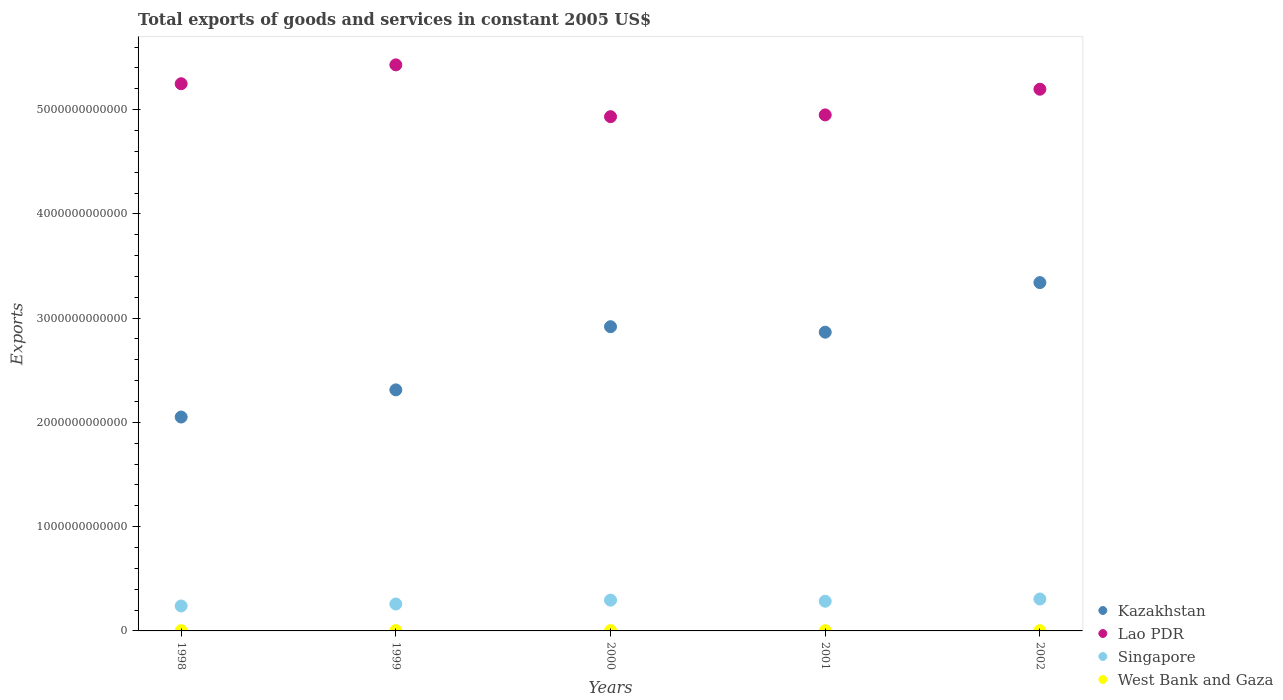How many different coloured dotlines are there?
Offer a terse response. 4. What is the total exports of goods and services in West Bank and Gaza in 2000?
Keep it short and to the point. 3.59e+09. Across all years, what is the maximum total exports of goods and services in Kazakhstan?
Keep it short and to the point. 3.34e+12. Across all years, what is the minimum total exports of goods and services in West Bank and Gaza?
Provide a succinct answer. 2.28e+09. In which year was the total exports of goods and services in Kazakhstan minimum?
Your answer should be compact. 1998. What is the total total exports of goods and services in Kazakhstan in the graph?
Give a very brief answer. 1.35e+13. What is the difference between the total exports of goods and services in West Bank and Gaza in 1998 and that in 2002?
Provide a short and direct response. 4.20e+08. What is the difference between the total exports of goods and services in Singapore in 2002 and the total exports of goods and services in Kazakhstan in 2000?
Your answer should be compact. -2.61e+12. What is the average total exports of goods and services in Lao PDR per year?
Your response must be concise. 5.15e+12. In the year 1998, what is the difference between the total exports of goods and services in Singapore and total exports of goods and services in Kazakhstan?
Provide a succinct answer. -1.81e+12. What is the ratio of the total exports of goods and services in Kazakhstan in 1998 to that in 1999?
Offer a very short reply. 0.89. Is the difference between the total exports of goods and services in Singapore in 1999 and 2002 greater than the difference between the total exports of goods and services in Kazakhstan in 1999 and 2002?
Your answer should be very brief. Yes. What is the difference between the highest and the second highest total exports of goods and services in West Bank and Gaza?
Your answer should be very brief. 4.78e+08. What is the difference between the highest and the lowest total exports of goods and services in Kazakhstan?
Your response must be concise. 1.29e+12. In how many years, is the total exports of goods and services in Kazakhstan greater than the average total exports of goods and services in Kazakhstan taken over all years?
Your answer should be compact. 3. Is the total exports of goods and services in Singapore strictly less than the total exports of goods and services in West Bank and Gaza over the years?
Your answer should be compact. No. What is the difference between two consecutive major ticks on the Y-axis?
Keep it short and to the point. 1.00e+12. Does the graph contain any zero values?
Provide a succinct answer. No. Does the graph contain grids?
Ensure brevity in your answer.  No. How are the legend labels stacked?
Your answer should be compact. Vertical. What is the title of the graph?
Provide a short and direct response. Total exports of goods and services in constant 2005 US$. Does "Guinea" appear as one of the legend labels in the graph?
Keep it short and to the point. No. What is the label or title of the Y-axis?
Provide a succinct answer. Exports. What is the Exports in Kazakhstan in 1998?
Your answer should be compact. 2.05e+12. What is the Exports of Lao PDR in 1998?
Keep it short and to the point. 5.25e+12. What is the Exports in Singapore in 1998?
Your answer should be compact. 2.39e+11. What is the Exports of West Bank and Gaza in 1998?
Ensure brevity in your answer.  2.70e+09. What is the Exports in Kazakhstan in 1999?
Offer a very short reply. 2.31e+12. What is the Exports in Lao PDR in 1999?
Keep it short and to the point. 5.43e+12. What is the Exports of Singapore in 1999?
Offer a terse response. 2.58e+11. What is the Exports of West Bank and Gaza in 1999?
Ensure brevity in your answer.  3.11e+09. What is the Exports of Kazakhstan in 2000?
Your response must be concise. 2.92e+12. What is the Exports of Lao PDR in 2000?
Ensure brevity in your answer.  4.93e+12. What is the Exports in Singapore in 2000?
Keep it short and to the point. 2.95e+11. What is the Exports of West Bank and Gaza in 2000?
Provide a succinct answer. 3.59e+09. What is the Exports of Kazakhstan in 2001?
Keep it short and to the point. 2.87e+12. What is the Exports in Lao PDR in 2001?
Provide a succinct answer. 4.95e+12. What is the Exports of Singapore in 2001?
Offer a very short reply. 2.85e+11. What is the Exports of West Bank and Gaza in 2001?
Your response must be concise. 2.48e+09. What is the Exports in Kazakhstan in 2002?
Make the answer very short. 3.34e+12. What is the Exports of Lao PDR in 2002?
Your answer should be very brief. 5.20e+12. What is the Exports in Singapore in 2002?
Provide a succinct answer. 3.06e+11. What is the Exports in West Bank and Gaza in 2002?
Provide a succinct answer. 2.28e+09. Across all years, what is the maximum Exports of Kazakhstan?
Your answer should be compact. 3.34e+12. Across all years, what is the maximum Exports in Lao PDR?
Your response must be concise. 5.43e+12. Across all years, what is the maximum Exports in Singapore?
Ensure brevity in your answer.  3.06e+11. Across all years, what is the maximum Exports in West Bank and Gaza?
Keep it short and to the point. 3.59e+09. Across all years, what is the minimum Exports in Kazakhstan?
Offer a terse response. 2.05e+12. Across all years, what is the minimum Exports in Lao PDR?
Give a very brief answer. 4.93e+12. Across all years, what is the minimum Exports of Singapore?
Your response must be concise. 2.39e+11. Across all years, what is the minimum Exports in West Bank and Gaza?
Make the answer very short. 2.28e+09. What is the total Exports of Kazakhstan in the graph?
Keep it short and to the point. 1.35e+13. What is the total Exports in Lao PDR in the graph?
Give a very brief answer. 2.58e+13. What is the total Exports of Singapore in the graph?
Ensure brevity in your answer.  1.38e+12. What is the total Exports in West Bank and Gaza in the graph?
Offer a very short reply. 1.42e+1. What is the difference between the Exports in Kazakhstan in 1998 and that in 1999?
Give a very brief answer. -2.61e+11. What is the difference between the Exports in Lao PDR in 1998 and that in 1999?
Your answer should be compact. -1.81e+11. What is the difference between the Exports in Singapore in 1998 and that in 1999?
Offer a terse response. -1.87e+1. What is the difference between the Exports of West Bank and Gaza in 1998 and that in 1999?
Ensure brevity in your answer.  -4.09e+08. What is the difference between the Exports of Kazakhstan in 1998 and that in 2000?
Ensure brevity in your answer.  -8.66e+11. What is the difference between the Exports in Lao PDR in 1998 and that in 2000?
Make the answer very short. 3.16e+11. What is the difference between the Exports of Singapore in 1998 and that in 2000?
Give a very brief answer. -5.60e+1. What is the difference between the Exports of West Bank and Gaza in 1998 and that in 2000?
Offer a terse response. -8.88e+08. What is the difference between the Exports in Kazakhstan in 1998 and that in 2001?
Offer a terse response. -8.14e+11. What is the difference between the Exports of Lao PDR in 1998 and that in 2001?
Provide a succinct answer. 2.99e+11. What is the difference between the Exports in Singapore in 1998 and that in 2001?
Offer a very short reply. -4.55e+1. What is the difference between the Exports of West Bank and Gaza in 1998 and that in 2001?
Provide a succinct answer. 2.17e+08. What is the difference between the Exports in Kazakhstan in 1998 and that in 2002?
Give a very brief answer. -1.29e+12. What is the difference between the Exports of Lao PDR in 1998 and that in 2002?
Give a very brief answer. 5.26e+1. What is the difference between the Exports of Singapore in 1998 and that in 2002?
Give a very brief answer. -6.69e+1. What is the difference between the Exports in West Bank and Gaza in 1998 and that in 2002?
Provide a short and direct response. 4.20e+08. What is the difference between the Exports in Kazakhstan in 1999 and that in 2000?
Your answer should be compact. -6.06e+11. What is the difference between the Exports in Lao PDR in 1999 and that in 2000?
Provide a short and direct response. 4.97e+11. What is the difference between the Exports of Singapore in 1999 and that in 2000?
Offer a terse response. -3.72e+1. What is the difference between the Exports in West Bank and Gaza in 1999 and that in 2000?
Your answer should be very brief. -4.78e+08. What is the difference between the Exports of Kazakhstan in 1999 and that in 2001?
Make the answer very short. -5.53e+11. What is the difference between the Exports of Lao PDR in 1999 and that in 2001?
Ensure brevity in your answer.  4.80e+11. What is the difference between the Exports of Singapore in 1999 and that in 2001?
Provide a short and direct response. -2.68e+1. What is the difference between the Exports in West Bank and Gaza in 1999 and that in 2001?
Provide a short and direct response. 6.27e+08. What is the difference between the Exports in Kazakhstan in 1999 and that in 2002?
Your answer should be compact. -1.03e+12. What is the difference between the Exports of Lao PDR in 1999 and that in 2002?
Give a very brief answer. 2.34e+11. What is the difference between the Exports of Singapore in 1999 and that in 2002?
Give a very brief answer. -4.81e+1. What is the difference between the Exports in West Bank and Gaza in 1999 and that in 2002?
Give a very brief answer. 8.29e+08. What is the difference between the Exports of Kazakhstan in 2000 and that in 2001?
Your answer should be compact. 5.25e+1. What is the difference between the Exports in Lao PDR in 2000 and that in 2001?
Your answer should be compact. -1.71e+1. What is the difference between the Exports in Singapore in 2000 and that in 2001?
Make the answer very short. 1.04e+1. What is the difference between the Exports in West Bank and Gaza in 2000 and that in 2001?
Give a very brief answer. 1.10e+09. What is the difference between the Exports of Kazakhstan in 2000 and that in 2002?
Offer a very short reply. -4.23e+11. What is the difference between the Exports of Lao PDR in 2000 and that in 2002?
Offer a terse response. -2.63e+11. What is the difference between the Exports in Singapore in 2000 and that in 2002?
Offer a terse response. -1.09e+1. What is the difference between the Exports in West Bank and Gaza in 2000 and that in 2002?
Your answer should be very brief. 1.31e+09. What is the difference between the Exports of Kazakhstan in 2001 and that in 2002?
Ensure brevity in your answer.  -4.76e+11. What is the difference between the Exports of Lao PDR in 2001 and that in 2002?
Your response must be concise. -2.46e+11. What is the difference between the Exports of Singapore in 2001 and that in 2002?
Give a very brief answer. -2.13e+1. What is the difference between the Exports in West Bank and Gaza in 2001 and that in 2002?
Keep it short and to the point. 2.03e+08. What is the difference between the Exports of Kazakhstan in 1998 and the Exports of Lao PDR in 1999?
Your response must be concise. -3.38e+12. What is the difference between the Exports in Kazakhstan in 1998 and the Exports in Singapore in 1999?
Offer a terse response. 1.79e+12. What is the difference between the Exports in Kazakhstan in 1998 and the Exports in West Bank and Gaza in 1999?
Provide a short and direct response. 2.05e+12. What is the difference between the Exports in Lao PDR in 1998 and the Exports in Singapore in 1999?
Provide a succinct answer. 4.99e+12. What is the difference between the Exports of Lao PDR in 1998 and the Exports of West Bank and Gaza in 1999?
Offer a very short reply. 5.25e+12. What is the difference between the Exports of Singapore in 1998 and the Exports of West Bank and Gaza in 1999?
Your answer should be compact. 2.36e+11. What is the difference between the Exports in Kazakhstan in 1998 and the Exports in Lao PDR in 2000?
Offer a very short reply. -2.88e+12. What is the difference between the Exports in Kazakhstan in 1998 and the Exports in Singapore in 2000?
Your response must be concise. 1.76e+12. What is the difference between the Exports of Kazakhstan in 1998 and the Exports of West Bank and Gaza in 2000?
Provide a short and direct response. 2.05e+12. What is the difference between the Exports in Lao PDR in 1998 and the Exports in Singapore in 2000?
Offer a very short reply. 4.95e+12. What is the difference between the Exports in Lao PDR in 1998 and the Exports in West Bank and Gaza in 2000?
Make the answer very short. 5.24e+12. What is the difference between the Exports of Singapore in 1998 and the Exports of West Bank and Gaza in 2000?
Your answer should be very brief. 2.36e+11. What is the difference between the Exports in Kazakhstan in 1998 and the Exports in Lao PDR in 2001?
Provide a succinct answer. -2.90e+12. What is the difference between the Exports of Kazakhstan in 1998 and the Exports of Singapore in 2001?
Ensure brevity in your answer.  1.77e+12. What is the difference between the Exports in Kazakhstan in 1998 and the Exports in West Bank and Gaza in 2001?
Your response must be concise. 2.05e+12. What is the difference between the Exports in Lao PDR in 1998 and the Exports in Singapore in 2001?
Keep it short and to the point. 4.96e+12. What is the difference between the Exports in Lao PDR in 1998 and the Exports in West Bank and Gaza in 2001?
Keep it short and to the point. 5.25e+12. What is the difference between the Exports in Singapore in 1998 and the Exports in West Bank and Gaza in 2001?
Give a very brief answer. 2.37e+11. What is the difference between the Exports of Kazakhstan in 1998 and the Exports of Lao PDR in 2002?
Provide a short and direct response. -3.14e+12. What is the difference between the Exports in Kazakhstan in 1998 and the Exports in Singapore in 2002?
Your answer should be very brief. 1.75e+12. What is the difference between the Exports of Kazakhstan in 1998 and the Exports of West Bank and Gaza in 2002?
Offer a very short reply. 2.05e+12. What is the difference between the Exports of Lao PDR in 1998 and the Exports of Singapore in 2002?
Keep it short and to the point. 4.94e+12. What is the difference between the Exports of Lao PDR in 1998 and the Exports of West Bank and Gaza in 2002?
Your response must be concise. 5.25e+12. What is the difference between the Exports in Singapore in 1998 and the Exports in West Bank and Gaza in 2002?
Keep it short and to the point. 2.37e+11. What is the difference between the Exports in Kazakhstan in 1999 and the Exports in Lao PDR in 2000?
Offer a very short reply. -2.62e+12. What is the difference between the Exports of Kazakhstan in 1999 and the Exports of Singapore in 2000?
Offer a very short reply. 2.02e+12. What is the difference between the Exports of Kazakhstan in 1999 and the Exports of West Bank and Gaza in 2000?
Ensure brevity in your answer.  2.31e+12. What is the difference between the Exports in Lao PDR in 1999 and the Exports in Singapore in 2000?
Your answer should be very brief. 5.13e+12. What is the difference between the Exports of Lao PDR in 1999 and the Exports of West Bank and Gaza in 2000?
Your answer should be compact. 5.43e+12. What is the difference between the Exports of Singapore in 1999 and the Exports of West Bank and Gaza in 2000?
Your answer should be compact. 2.54e+11. What is the difference between the Exports of Kazakhstan in 1999 and the Exports of Lao PDR in 2001?
Offer a very short reply. -2.64e+12. What is the difference between the Exports in Kazakhstan in 1999 and the Exports in Singapore in 2001?
Provide a succinct answer. 2.03e+12. What is the difference between the Exports in Kazakhstan in 1999 and the Exports in West Bank and Gaza in 2001?
Offer a very short reply. 2.31e+12. What is the difference between the Exports in Lao PDR in 1999 and the Exports in Singapore in 2001?
Your answer should be very brief. 5.14e+12. What is the difference between the Exports in Lao PDR in 1999 and the Exports in West Bank and Gaza in 2001?
Give a very brief answer. 5.43e+12. What is the difference between the Exports in Singapore in 1999 and the Exports in West Bank and Gaza in 2001?
Your answer should be compact. 2.56e+11. What is the difference between the Exports of Kazakhstan in 1999 and the Exports of Lao PDR in 2002?
Keep it short and to the point. -2.88e+12. What is the difference between the Exports in Kazakhstan in 1999 and the Exports in Singapore in 2002?
Your answer should be very brief. 2.01e+12. What is the difference between the Exports of Kazakhstan in 1999 and the Exports of West Bank and Gaza in 2002?
Provide a short and direct response. 2.31e+12. What is the difference between the Exports of Lao PDR in 1999 and the Exports of Singapore in 2002?
Provide a succinct answer. 5.12e+12. What is the difference between the Exports of Lao PDR in 1999 and the Exports of West Bank and Gaza in 2002?
Your response must be concise. 5.43e+12. What is the difference between the Exports in Singapore in 1999 and the Exports in West Bank and Gaza in 2002?
Your answer should be very brief. 2.56e+11. What is the difference between the Exports of Kazakhstan in 2000 and the Exports of Lao PDR in 2001?
Your answer should be compact. -2.03e+12. What is the difference between the Exports in Kazakhstan in 2000 and the Exports in Singapore in 2001?
Offer a terse response. 2.63e+12. What is the difference between the Exports of Kazakhstan in 2000 and the Exports of West Bank and Gaza in 2001?
Your answer should be very brief. 2.92e+12. What is the difference between the Exports of Lao PDR in 2000 and the Exports of Singapore in 2001?
Give a very brief answer. 4.65e+12. What is the difference between the Exports of Lao PDR in 2000 and the Exports of West Bank and Gaza in 2001?
Your response must be concise. 4.93e+12. What is the difference between the Exports of Singapore in 2000 and the Exports of West Bank and Gaza in 2001?
Keep it short and to the point. 2.93e+11. What is the difference between the Exports in Kazakhstan in 2000 and the Exports in Lao PDR in 2002?
Ensure brevity in your answer.  -2.28e+12. What is the difference between the Exports of Kazakhstan in 2000 and the Exports of Singapore in 2002?
Keep it short and to the point. 2.61e+12. What is the difference between the Exports in Kazakhstan in 2000 and the Exports in West Bank and Gaza in 2002?
Your response must be concise. 2.92e+12. What is the difference between the Exports of Lao PDR in 2000 and the Exports of Singapore in 2002?
Ensure brevity in your answer.  4.63e+12. What is the difference between the Exports of Lao PDR in 2000 and the Exports of West Bank and Gaza in 2002?
Offer a terse response. 4.93e+12. What is the difference between the Exports of Singapore in 2000 and the Exports of West Bank and Gaza in 2002?
Ensure brevity in your answer.  2.93e+11. What is the difference between the Exports of Kazakhstan in 2001 and the Exports of Lao PDR in 2002?
Provide a short and direct response. -2.33e+12. What is the difference between the Exports of Kazakhstan in 2001 and the Exports of Singapore in 2002?
Make the answer very short. 2.56e+12. What is the difference between the Exports of Kazakhstan in 2001 and the Exports of West Bank and Gaza in 2002?
Provide a succinct answer. 2.86e+12. What is the difference between the Exports in Lao PDR in 2001 and the Exports in Singapore in 2002?
Your response must be concise. 4.64e+12. What is the difference between the Exports of Lao PDR in 2001 and the Exports of West Bank and Gaza in 2002?
Provide a succinct answer. 4.95e+12. What is the difference between the Exports in Singapore in 2001 and the Exports in West Bank and Gaza in 2002?
Offer a very short reply. 2.83e+11. What is the average Exports in Kazakhstan per year?
Provide a succinct answer. 2.70e+12. What is the average Exports of Lao PDR per year?
Give a very brief answer. 5.15e+12. What is the average Exports of Singapore per year?
Provide a succinct answer. 2.77e+11. What is the average Exports of West Bank and Gaza per year?
Your response must be concise. 2.83e+09. In the year 1998, what is the difference between the Exports in Kazakhstan and Exports in Lao PDR?
Your response must be concise. -3.20e+12. In the year 1998, what is the difference between the Exports in Kazakhstan and Exports in Singapore?
Make the answer very short. 1.81e+12. In the year 1998, what is the difference between the Exports of Kazakhstan and Exports of West Bank and Gaza?
Make the answer very short. 2.05e+12. In the year 1998, what is the difference between the Exports of Lao PDR and Exports of Singapore?
Offer a very short reply. 5.01e+12. In the year 1998, what is the difference between the Exports of Lao PDR and Exports of West Bank and Gaza?
Provide a succinct answer. 5.25e+12. In the year 1998, what is the difference between the Exports in Singapore and Exports in West Bank and Gaza?
Make the answer very short. 2.37e+11. In the year 1999, what is the difference between the Exports in Kazakhstan and Exports in Lao PDR?
Ensure brevity in your answer.  -3.12e+12. In the year 1999, what is the difference between the Exports in Kazakhstan and Exports in Singapore?
Your answer should be compact. 2.05e+12. In the year 1999, what is the difference between the Exports in Kazakhstan and Exports in West Bank and Gaza?
Your response must be concise. 2.31e+12. In the year 1999, what is the difference between the Exports in Lao PDR and Exports in Singapore?
Ensure brevity in your answer.  5.17e+12. In the year 1999, what is the difference between the Exports of Lao PDR and Exports of West Bank and Gaza?
Keep it short and to the point. 5.43e+12. In the year 1999, what is the difference between the Exports of Singapore and Exports of West Bank and Gaza?
Ensure brevity in your answer.  2.55e+11. In the year 2000, what is the difference between the Exports of Kazakhstan and Exports of Lao PDR?
Your answer should be very brief. -2.01e+12. In the year 2000, what is the difference between the Exports of Kazakhstan and Exports of Singapore?
Provide a short and direct response. 2.62e+12. In the year 2000, what is the difference between the Exports in Kazakhstan and Exports in West Bank and Gaza?
Give a very brief answer. 2.91e+12. In the year 2000, what is the difference between the Exports in Lao PDR and Exports in Singapore?
Provide a succinct answer. 4.64e+12. In the year 2000, what is the difference between the Exports in Lao PDR and Exports in West Bank and Gaza?
Give a very brief answer. 4.93e+12. In the year 2000, what is the difference between the Exports in Singapore and Exports in West Bank and Gaza?
Provide a succinct answer. 2.92e+11. In the year 2001, what is the difference between the Exports of Kazakhstan and Exports of Lao PDR?
Offer a very short reply. -2.08e+12. In the year 2001, what is the difference between the Exports in Kazakhstan and Exports in Singapore?
Offer a very short reply. 2.58e+12. In the year 2001, what is the difference between the Exports in Kazakhstan and Exports in West Bank and Gaza?
Offer a terse response. 2.86e+12. In the year 2001, what is the difference between the Exports in Lao PDR and Exports in Singapore?
Your answer should be very brief. 4.66e+12. In the year 2001, what is the difference between the Exports in Lao PDR and Exports in West Bank and Gaza?
Your answer should be very brief. 4.95e+12. In the year 2001, what is the difference between the Exports in Singapore and Exports in West Bank and Gaza?
Provide a succinct answer. 2.82e+11. In the year 2002, what is the difference between the Exports in Kazakhstan and Exports in Lao PDR?
Make the answer very short. -1.85e+12. In the year 2002, what is the difference between the Exports of Kazakhstan and Exports of Singapore?
Your answer should be very brief. 3.03e+12. In the year 2002, what is the difference between the Exports of Kazakhstan and Exports of West Bank and Gaza?
Your answer should be compact. 3.34e+12. In the year 2002, what is the difference between the Exports of Lao PDR and Exports of Singapore?
Keep it short and to the point. 4.89e+12. In the year 2002, what is the difference between the Exports in Lao PDR and Exports in West Bank and Gaza?
Give a very brief answer. 5.19e+12. In the year 2002, what is the difference between the Exports of Singapore and Exports of West Bank and Gaza?
Your response must be concise. 3.04e+11. What is the ratio of the Exports of Kazakhstan in 1998 to that in 1999?
Give a very brief answer. 0.89. What is the ratio of the Exports in Lao PDR in 1998 to that in 1999?
Provide a short and direct response. 0.97. What is the ratio of the Exports of Singapore in 1998 to that in 1999?
Ensure brevity in your answer.  0.93. What is the ratio of the Exports of West Bank and Gaza in 1998 to that in 1999?
Offer a terse response. 0.87. What is the ratio of the Exports of Kazakhstan in 1998 to that in 2000?
Keep it short and to the point. 0.7. What is the ratio of the Exports in Lao PDR in 1998 to that in 2000?
Your answer should be very brief. 1.06. What is the ratio of the Exports in Singapore in 1998 to that in 2000?
Provide a succinct answer. 0.81. What is the ratio of the Exports in West Bank and Gaza in 1998 to that in 2000?
Give a very brief answer. 0.75. What is the ratio of the Exports of Kazakhstan in 1998 to that in 2001?
Your response must be concise. 0.72. What is the ratio of the Exports of Lao PDR in 1998 to that in 2001?
Your answer should be compact. 1.06. What is the ratio of the Exports of Singapore in 1998 to that in 2001?
Make the answer very short. 0.84. What is the ratio of the Exports of West Bank and Gaza in 1998 to that in 2001?
Make the answer very short. 1.09. What is the ratio of the Exports of Kazakhstan in 1998 to that in 2002?
Keep it short and to the point. 0.61. What is the ratio of the Exports of Singapore in 1998 to that in 2002?
Your answer should be compact. 0.78. What is the ratio of the Exports in West Bank and Gaza in 1998 to that in 2002?
Offer a terse response. 1.18. What is the ratio of the Exports in Kazakhstan in 1999 to that in 2000?
Make the answer very short. 0.79. What is the ratio of the Exports of Lao PDR in 1999 to that in 2000?
Give a very brief answer. 1.1. What is the ratio of the Exports in Singapore in 1999 to that in 2000?
Your response must be concise. 0.87. What is the ratio of the Exports in West Bank and Gaza in 1999 to that in 2000?
Your answer should be very brief. 0.87. What is the ratio of the Exports in Kazakhstan in 1999 to that in 2001?
Make the answer very short. 0.81. What is the ratio of the Exports of Lao PDR in 1999 to that in 2001?
Your answer should be very brief. 1.1. What is the ratio of the Exports of Singapore in 1999 to that in 2001?
Ensure brevity in your answer.  0.91. What is the ratio of the Exports of West Bank and Gaza in 1999 to that in 2001?
Provide a succinct answer. 1.25. What is the ratio of the Exports of Kazakhstan in 1999 to that in 2002?
Ensure brevity in your answer.  0.69. What is the ratio of the Exports of Lao PDR in 1999 to that in 2002?
Your answer should be compact. 1.04. What is the ratio of the Exports of Singapore in 1999 to that in 2002?
Provide a succinct answer. 0.84. What is the ratio of the Exports in West Bank and Gaza in 1999 to that in 2002?
Offer a terse response. 1.36. What is the ratio of the Exports of Kazakhstan in 2000 to that in 2001?
Make the answer very short. 1.02. What is the ratio of the Exports of Lao PDR in 2000 to that in 2001?
Ensure brevity in your answer.  1. What is the ratio of the Exports of Singapore in 2000 to that in 2001?
Keep it short and to the point. 1.04. What is the ratio of the Exports of West Bank and Gaza in 2000 to that in 2001?
Ensure brevity in your answer.  1.45. What is the ratio of the Exports of Kazakhstan in 2000 to that in 2002?
Offer a terse response. 0.87. What is the ratio of the Exports in Lao PDR in 2000 to that in 2002?
Give a very brief answer. 0.95. What is the ratio of the Exports in Singapore in 2000 to that in 2002?
Your answer should be very brief. 0.96. What is the ratio of the Exports of West Bank and Gaza in 2000 to that in 2002?
Offer a very short reply. 1.57. What is the ratio of the Exports in Kazakhstan in 2001 to that in 2002?
Your answer should be very brief. 0.86. What is the ratio of the Exports of Lao PDR in 2001 to that in 2002?
Give a very brief answer. 0.95. What is the ratio of the Exports of Singapore in 2001 to that in 2002?
Provide a short and direct response. 0.93. What is the ratio of the Exports of West Bank and Gaza in 2001 to that in 2002?
Your answer should be compact. 1.09. What is the difference between the highest and the second highest Exports of Kazakhstan?
Provide a short and direct response. 4.23e+11. What is the difference between the highest and the second highest Exports in Lao PDR?
Keep it short and to the point. 1.81e+11. What is the difference between the highest and the second highest Exports of Singapore?
Provide a succinct answer. 1.09e+1. What is the difference between the highest and the second highest Exports in West Bank and Gaza?
Give a very brief answer. 4.78e+08. What is the difference between the highest and the lowest Exports in Kazakhstan?
Give a very brief answer. 1.29e+12. What is the difference between the highest and the lowest Exports in Lao PDR?
Offer a terse response. 4.97e+11. What is the difference between the highest and the lowest Exports in Singapore?
Your response must be concise. 6.69e+1. What is the difference between the highest and the lowest Exports in West Bank and Gaza?
Make the answer very short. 1.31e+09. 